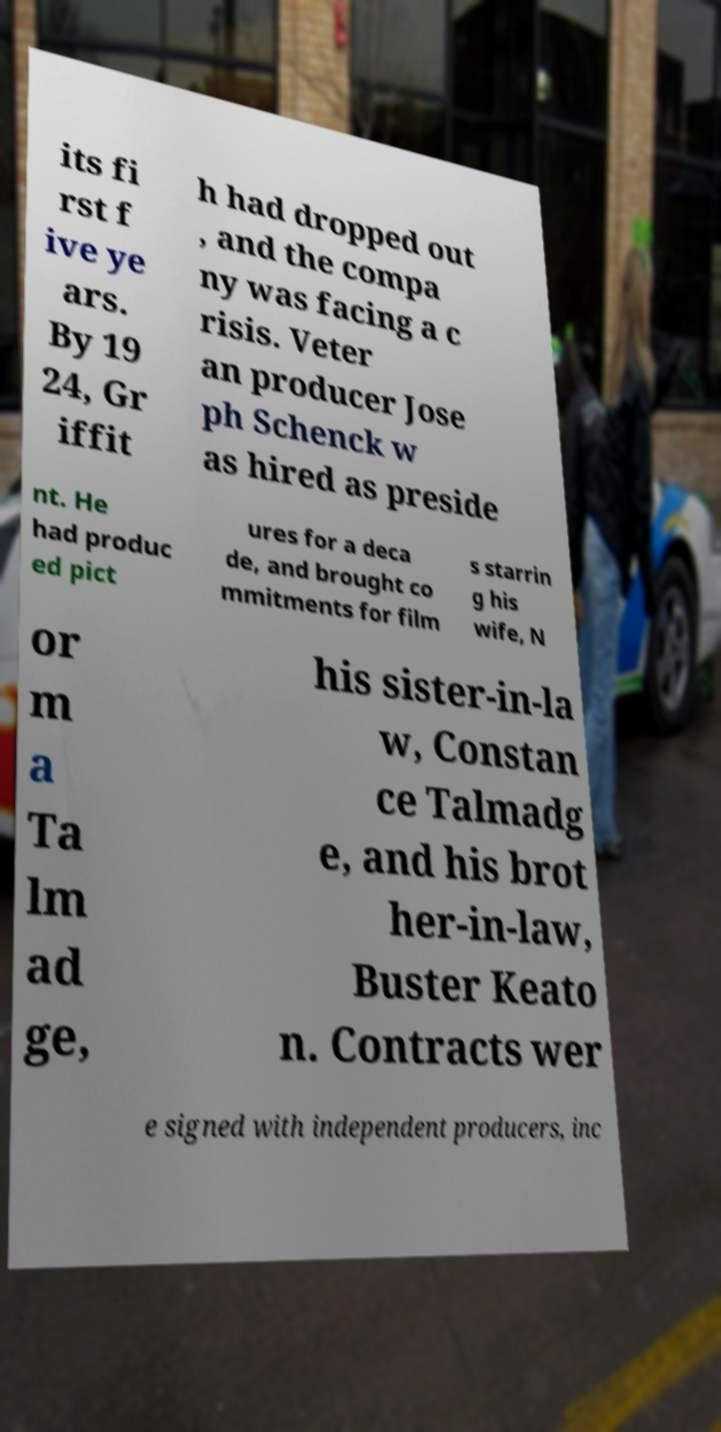Please read and relay the text visible in this image. What does it say? its fi rst f ive ye ars. By 19 24, Gr iffit h had dropped out , and the compa ny was facing a c risis. Veter an producer Jose ph Schenck w as hired as preside nt. He had produc ed pict ures for a deca de, and brought co mmitments for film s starrin g his wife, N or m a Ta lm ad ge, his sister-in-la w, Constan ce Talmadg e, and his brot her-in-law, Buster Keato n. Contracts wer e signed with independent producers, inc 